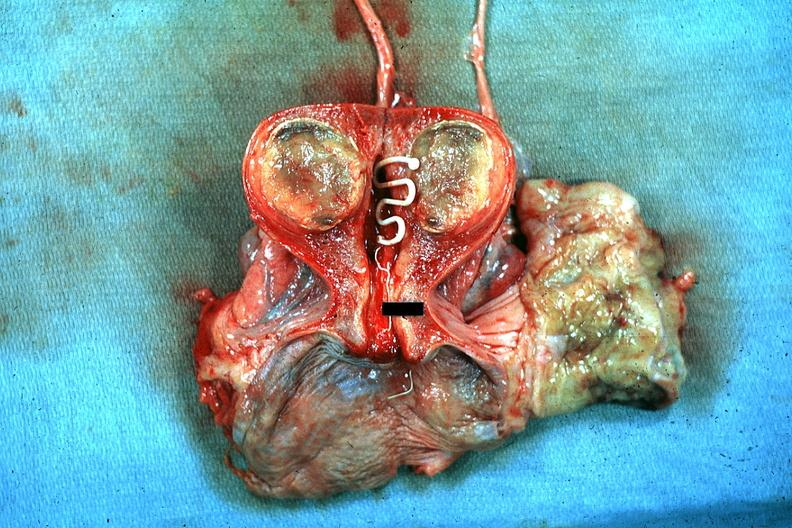s macerated stillborn present?
Answer the question using a single word or phrase. No 